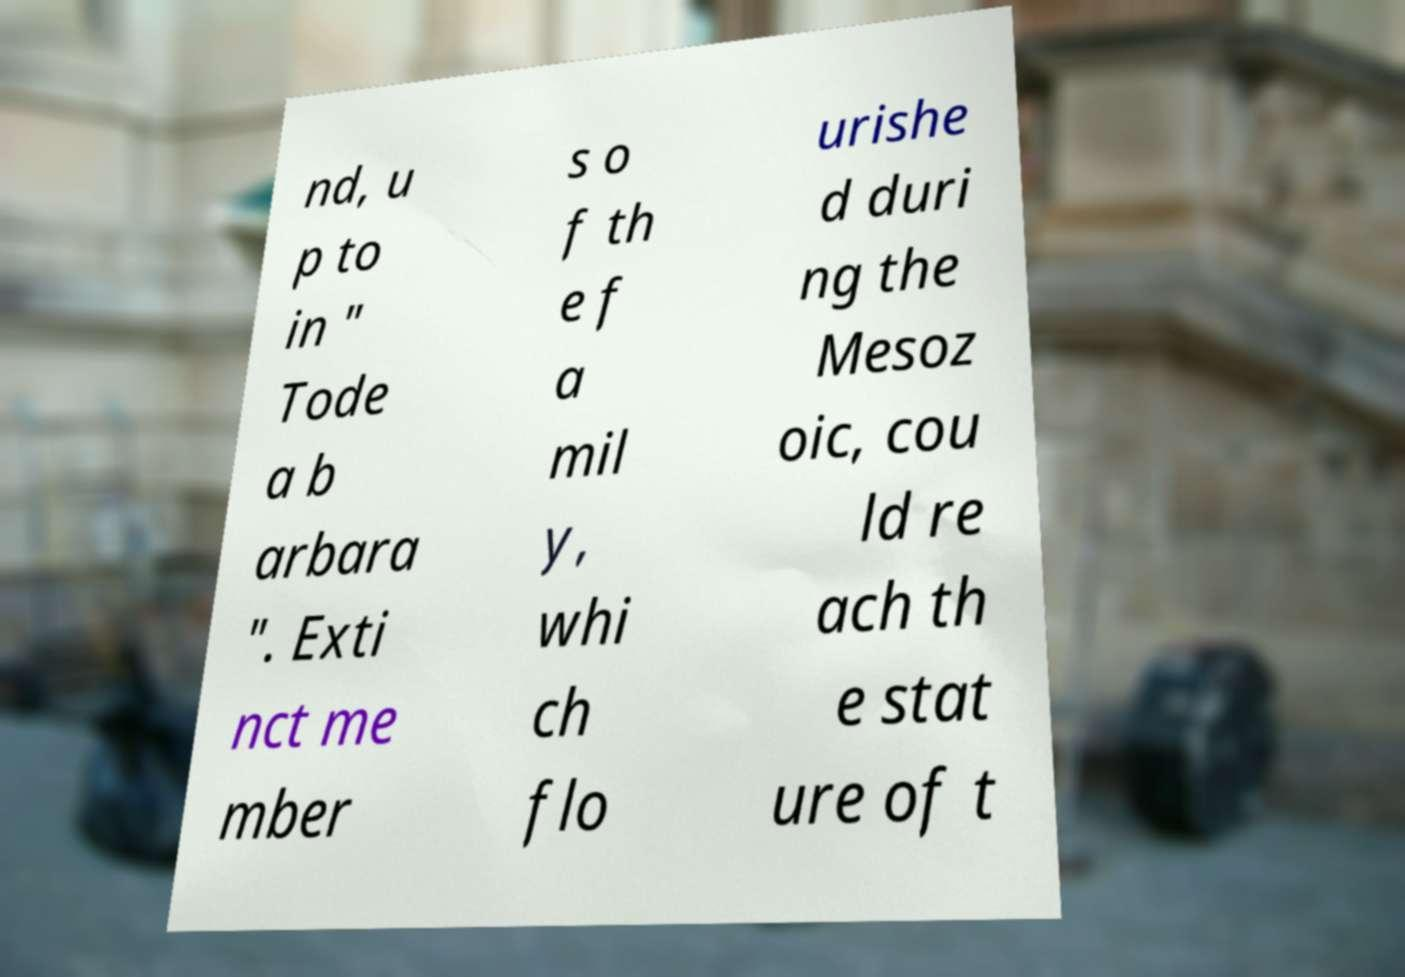Please identify and transcribe the text found in this image. nd, u p to in " Tode a b arbara ". Exti nct me mber s o f th e f a mil y, whi ch flo urishe d duri ng the Mesoz oic, cou ld re ach th e stat ure of t 